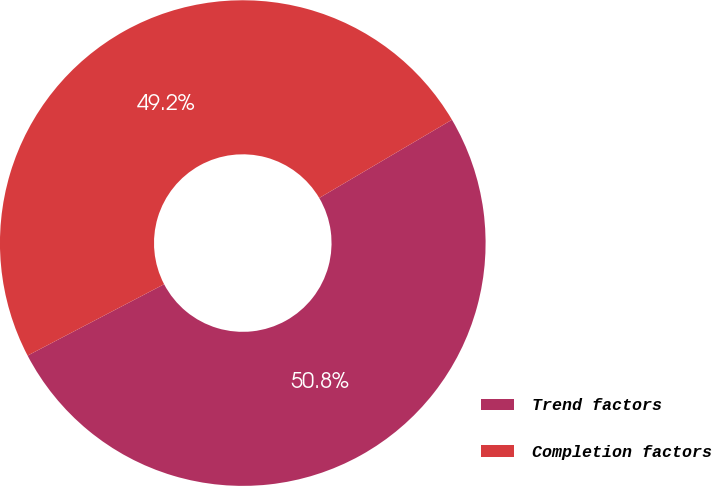<chart> <loc_0><loc_0><loc_500><loc_500><pie_chart><fcel>Trend factors<fcel>Completion factors<nl><fcel>50.81%<fcel>49.19%<nl></chart> 